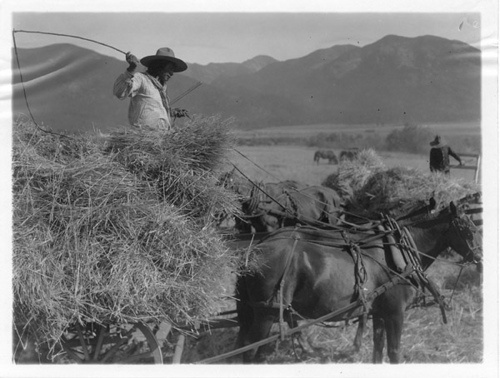Describe the objects in this image and their specific colors. I can see horse in white, black, gray, and lightgray tones, people in white, gray, darkgray, black, and lightgray tones, horse in black, gray, and white tones, horse in gray, black, and white tones, and horse in gray, black, and white tones in this image. 